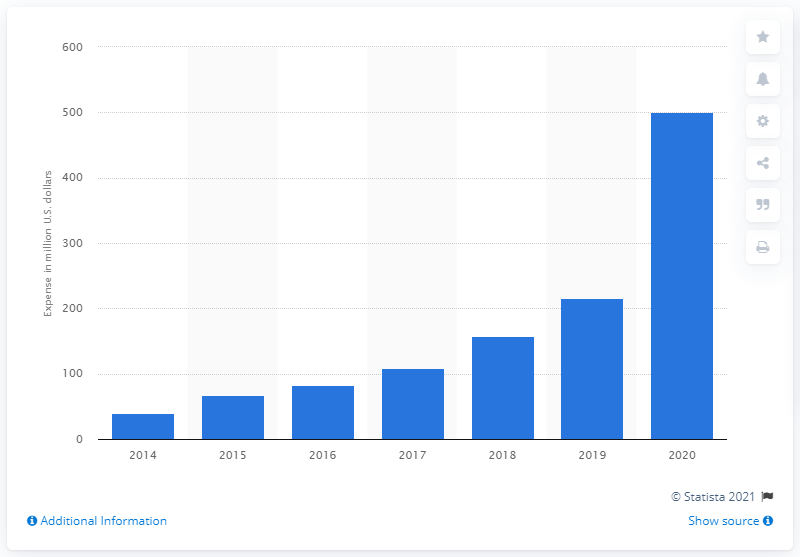Identify some key points in this picture. Etsy invested $500.76 in its marketing activities in the last reported year. 